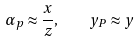<formula> <loc_0><loc_0><loc_500><loc_500>\alpha _ { p } \approx \frac { x } { z } , \quad y _ { P } \approx y</formula> 